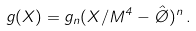Convert formula to latex. <formula><loc_0><loc_0><loc_500><loc_500>g ( X ) = g _ { n } ( X / M ^ { 4 } - \hat { \chi } ) ^ { n } \, .</formula> 